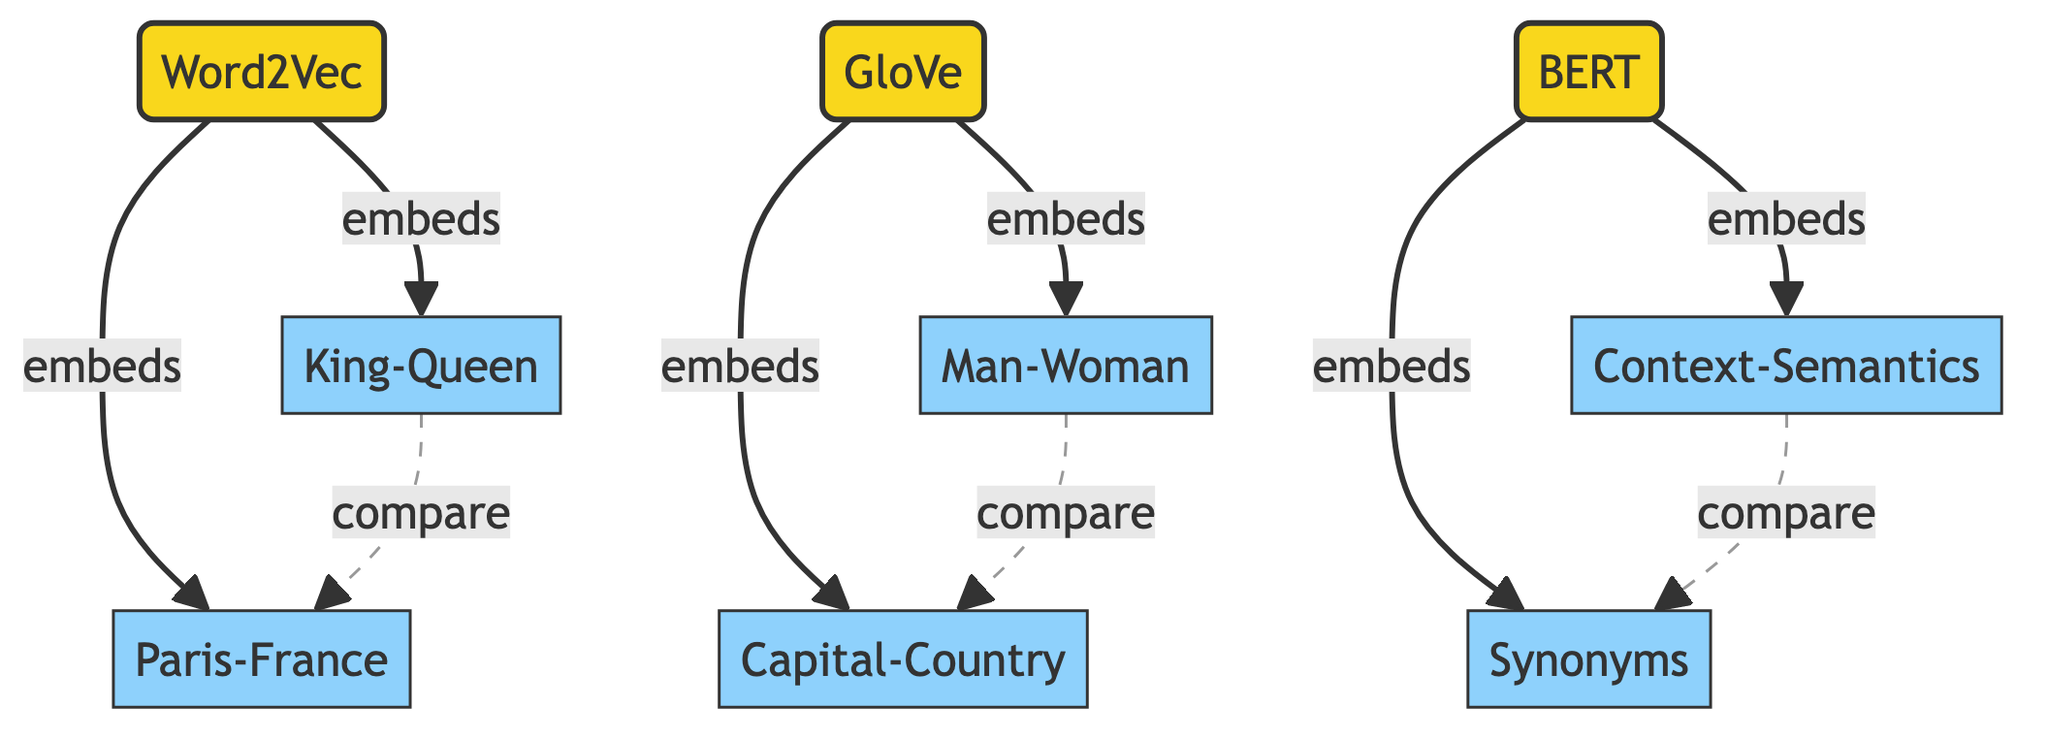What algorithms are represented in the diagram? The diagram shows three algorithms: Word2Vec, GloVe, and BERT. These are distinct nodes labeled as algorithms within the diagram.
Answer: Word2Vec, GloVe, BERT How many relationships are shown for Word2Vec? The diagram indicates that Word2Vec has two relationships: King-Queen and Paris-France. By counting the edges leading from the Word2Vec node, we find two.
Answer: 2 What is the relationship associated with GloVe? GloVe has two relationships: Man-Woman and Capital-Country. Each represents an embedded relationship from the GloVe node.
Answer: Man-Woman, Capital-Country Which relationship connects King-Queen and Paris-France? The diagram illustrates a compare relationship between King-Queen and Paris-France, indicated by a dashed connection line labeled "compare".
Answer: compare Are there any relationships associated with BERT? Yes, BERT has two relationships: Context-Semantics and Synonyms, shown as edges originating from the BERT node representing embeddings.
Answer: Context-Semantics, Synonyms How many total nodes does the diagram contain? The diagram features a total of eight nodes: three algorithms and five relationships. This sum is obtained by counting all nodes listed.
Answer: 8 Which embeddings correspond to the Man-Woman relationship? The Man-Woman relationship corresponds to the GloVe algorithm, as indicated by its embedded relationship from the GloVe node.
Answer: GloVe What type of relationship exists between Context-Semantics and Synonyms? The relationship between Context-Semantics and Synonyms is a compare relationship, represented by a dashed line between these two relationship nodes.
Answer: compare Which algorithm has the most relationships depicted in the diagram? Both Word2Vec and GloVe have two relationships each, while BERT also has two. Therefore, all three algorithms have the same number of relationships.
Answer: All equally, 2 each 